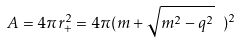Convert formula to latex. <formula><loc_0><loc_0><loc_500><loc_500>A = 4 \pi r _ { + } ^ { 2 } = 4 \pi ( m + \sqrt { m ^ { 2 } - q ^ { 2 } } \ ) ^ { 2 }</formula> 